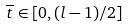<formula> <loc_0><loc_0><loc_500><loc_500>\overline { t } \in [ 0 , ( l - 1 ) / 2 ]</formula> 